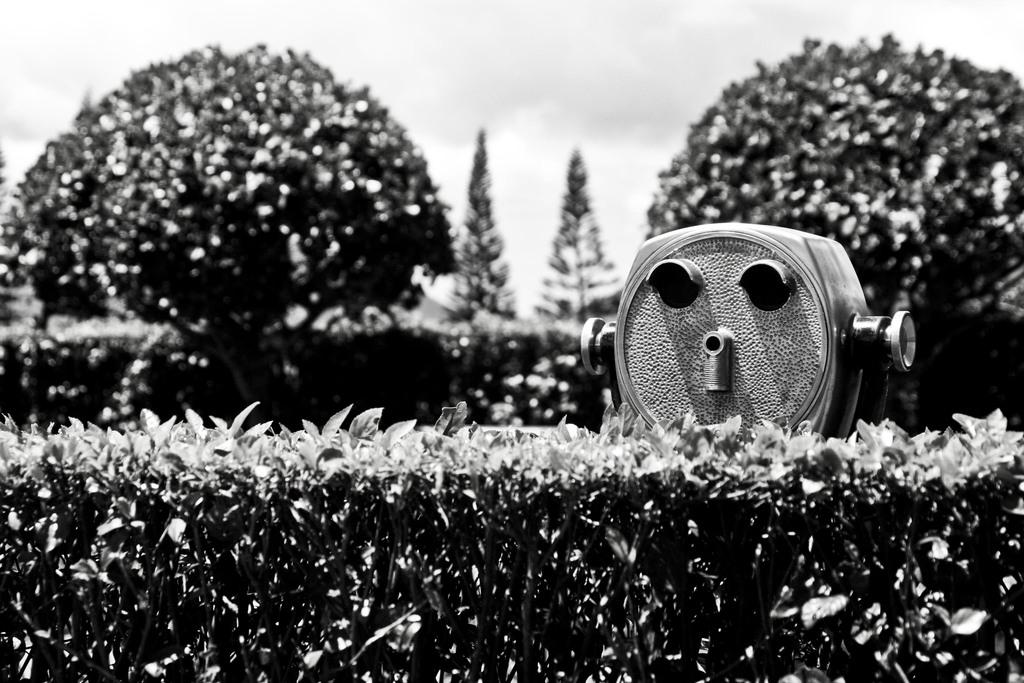What is the color scheme of the image? The image is black and white. What type of vegetation can be seen in the image? There are trees and plants in the image. Can you describe the object in the image? Unfortunately, the facts provided do not give any specific details about the object in the image. How does the mist affect the visibility of the plants in the image? There is no mist present in the image, as it is described as black and white. 